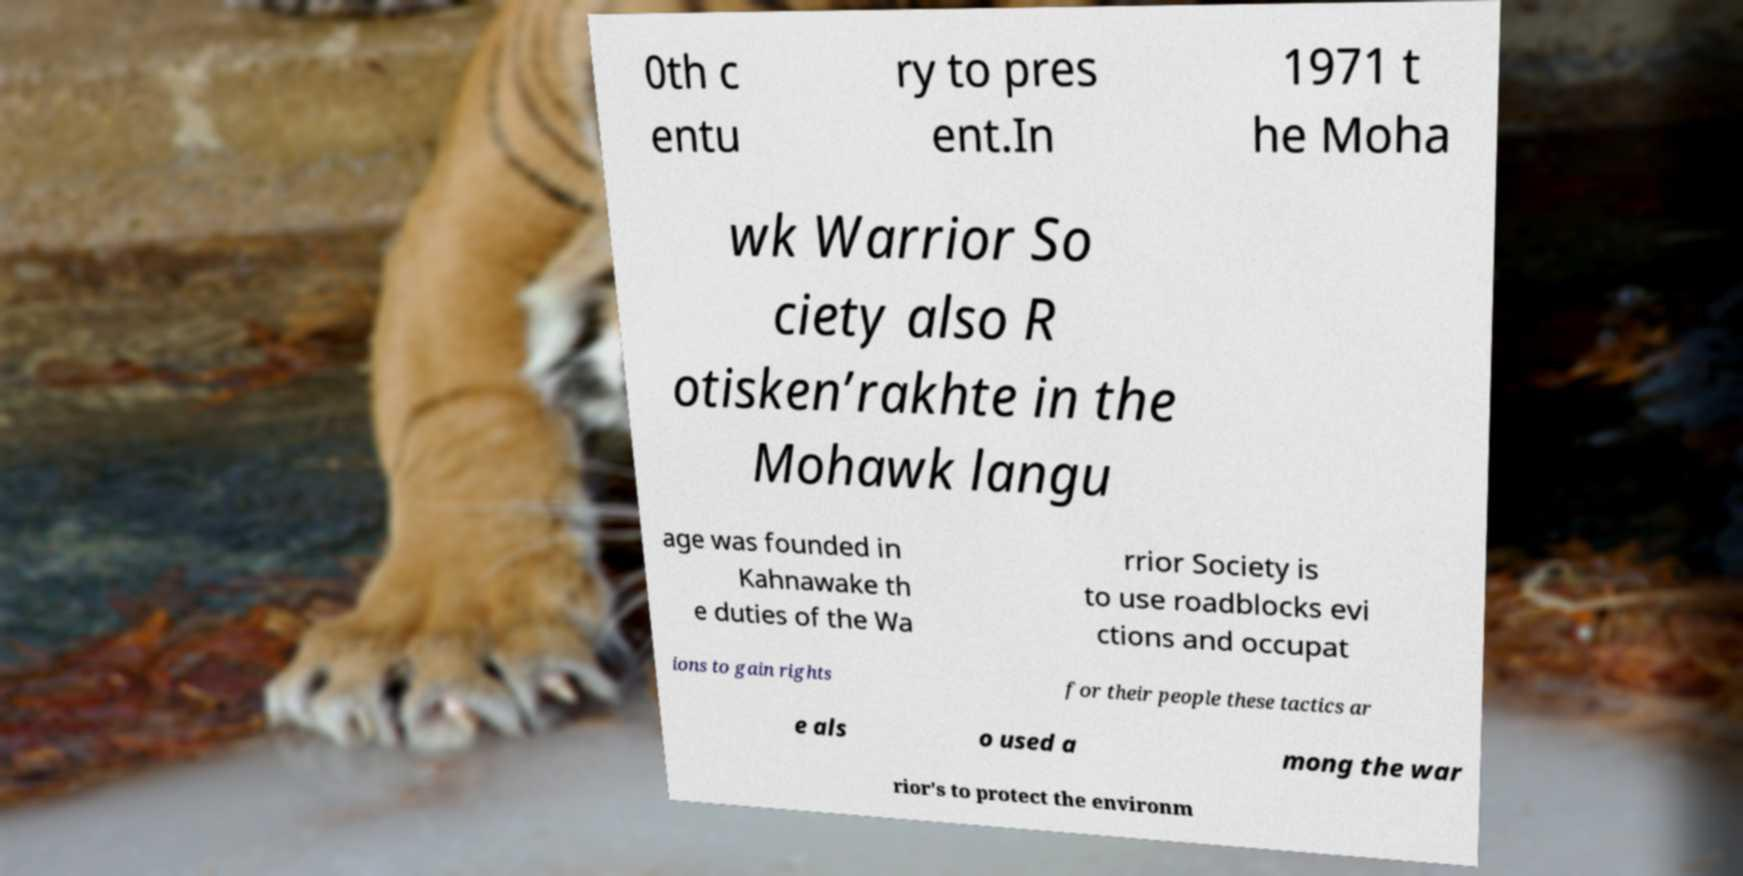Could you assist in decoding the text presented in this image and type it out clearly? 0th c entu ry to pres ent.In 1971 t he Moha wk Warrior So ciety also R otisken’rakhte in the Mohawk langu age was founded in Kahnawake th e duties of the Wa rrior Society is to use roadblocks evi ctions and occupat ions to gain rights for their people these tactics ar e als o used a mong the war rior's to protect the environm 